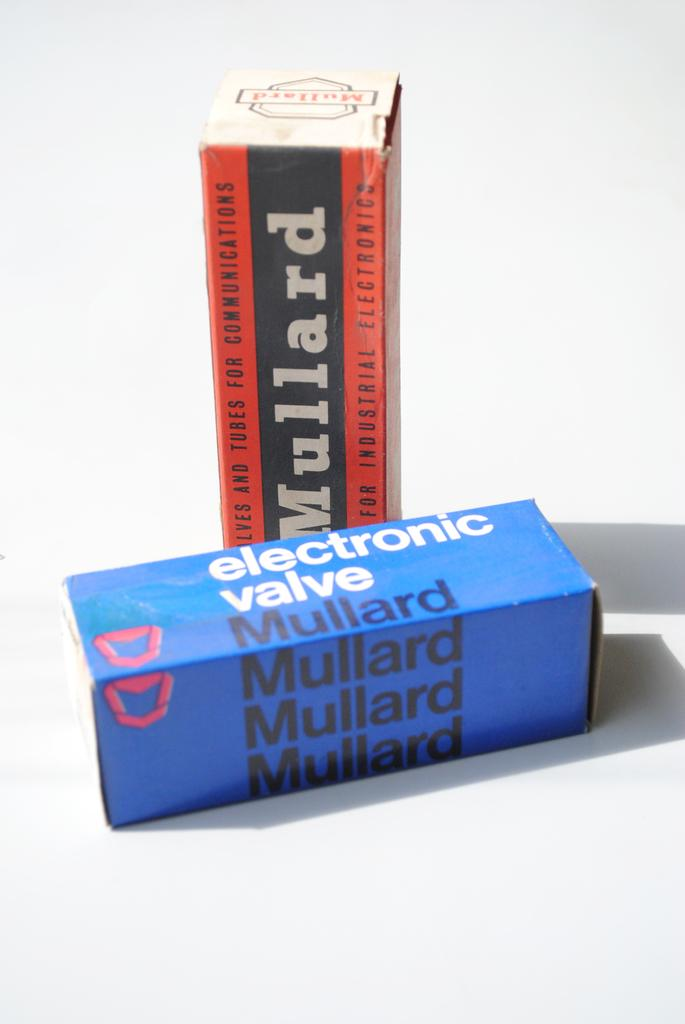<image>
Provide a brief description of the given image. A box for an electric valve sits in front of another box 